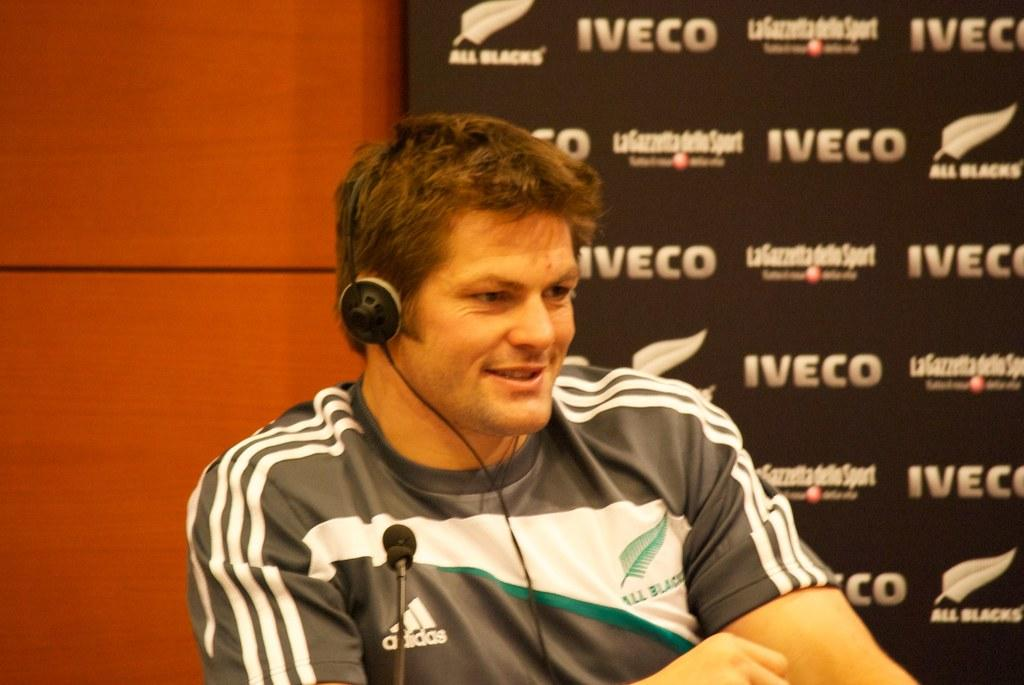<image>
Describe the image concisely. An adult man wearing an Adidas shirt talks into a microphone. 